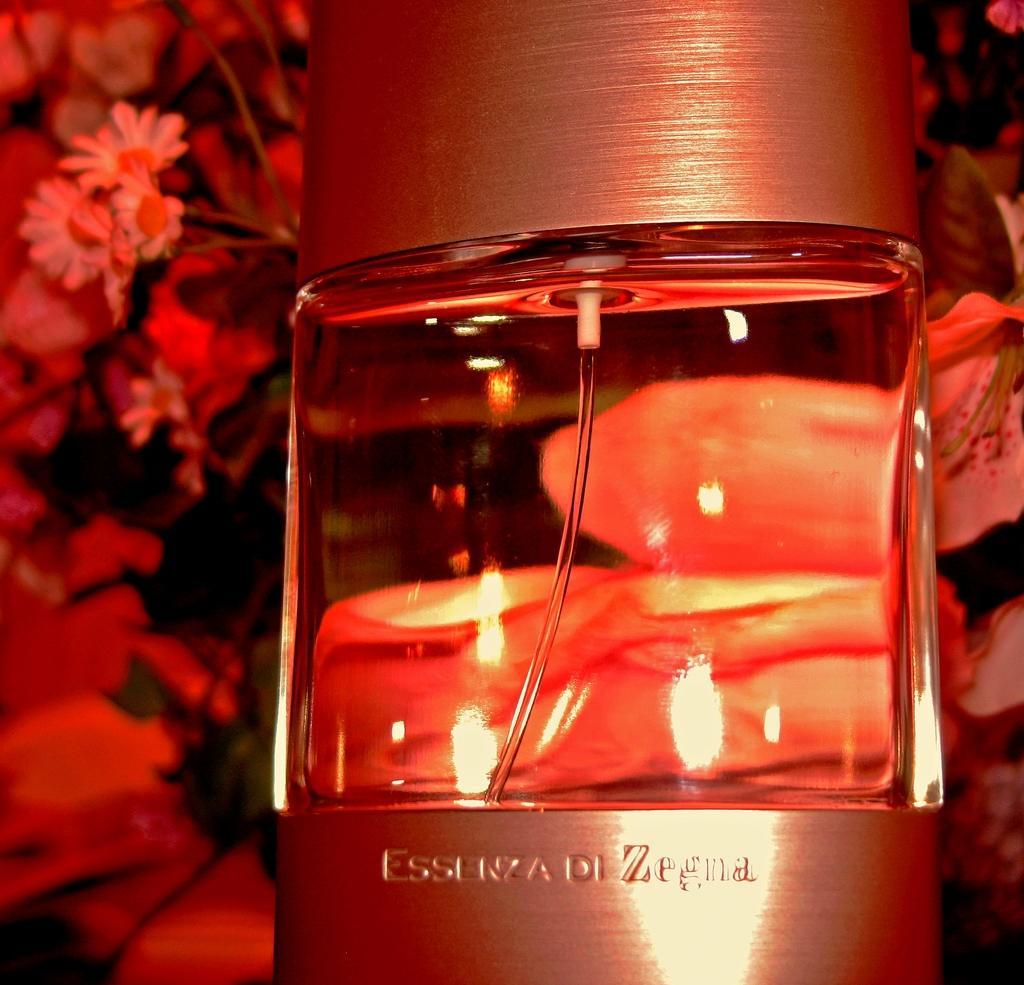Please provide a concise description of this image. A glass with water in it and in background we can see flowers of different colors. 